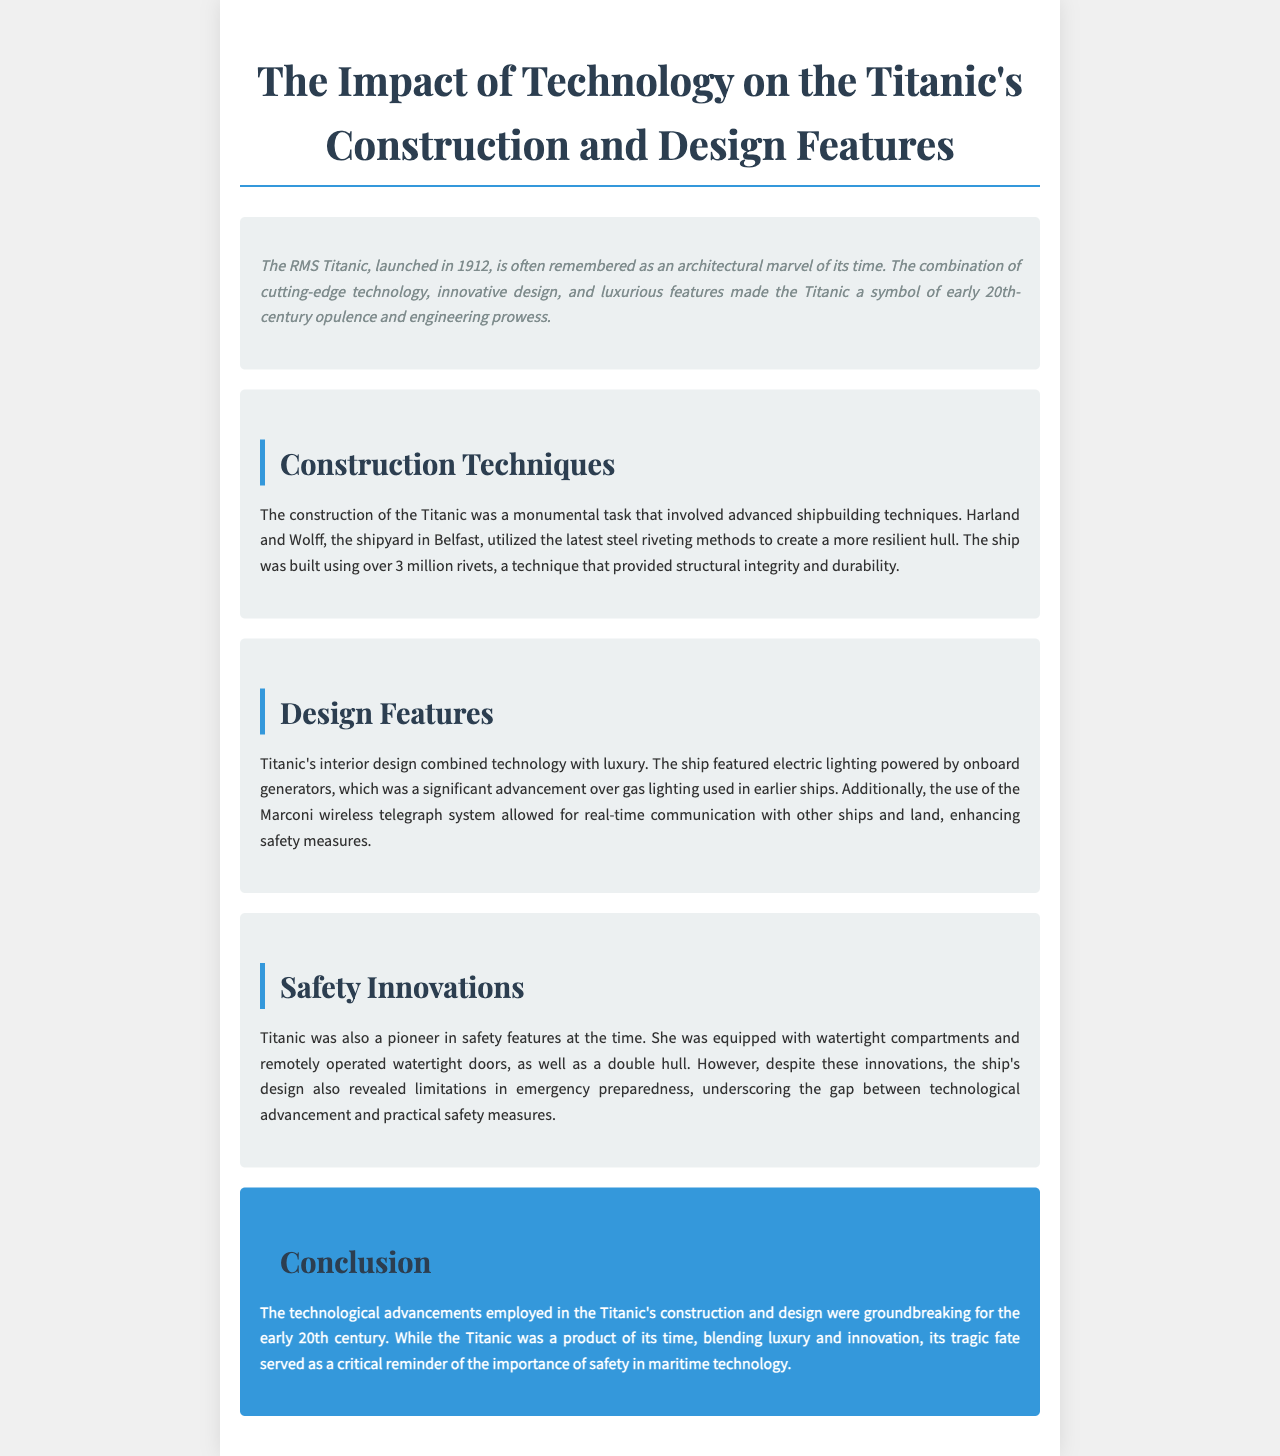what year was the Titanic launched? The document states that the Titanic was launched in 1912.
Answer: 1912 how many rivets were used in the construction of the Titanic? The document mentions that over 3 million rivets were used in the Titanic's construction.
Answer: over 3 million what system allowed for real-time communication on the Titanic? The document describes the Marconi wireless telegraph system as the technology that enabled real-time communication.
Answer: Marconi wireless telegraph system what safety feature did the Titanic include to enhance safety? The document lists watertight compartments as one of the safety innovations of the Titanic.
Answer: watertight compartments what was a significant power source for the Titanic's electric lighting? The document says that electric lighting was powered by onboard generators.
Answer: onboard generators why are the Titanic's design features described as innovative? The document highlights that the combination of luxury and advanced technology in the design made it a symbol of engineering prowess.
Answer: combination of luxury and advanced technology what type of report is this document? The structure and content indicate it is a report focused on the technological impact on Titanic's construction and design features.
Answer: report what limitation is mentioned regarding the Titanic's safety measures? The document notes that despite innovations, there was a limitation in emergency preparedness.
Answer: limitation in emergency preparedness 